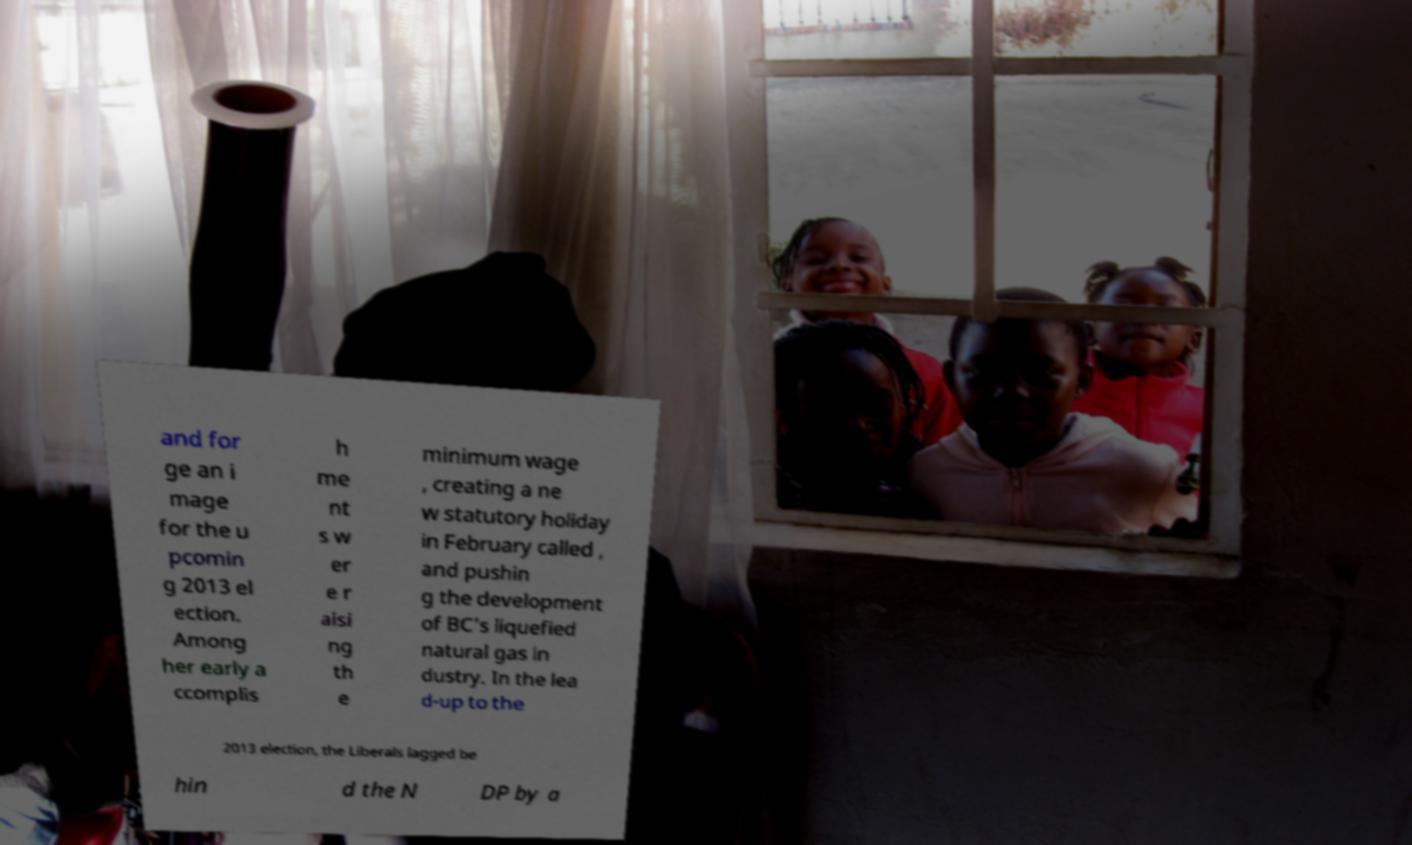Please read and relay the text visible in this image. What does it say? and for ge an i mage for the u pcomin g 2013 el ection. Among her early a ccomplis h me nt s w er e r aisi ng th e minimum wage , creating a ne w statutory holiday in February called , and pushin g the development of BC's liquefied natural gas in dustry. In the lea d-up to the 2013 election, the Liberals lagged be hin d the N DP by a 